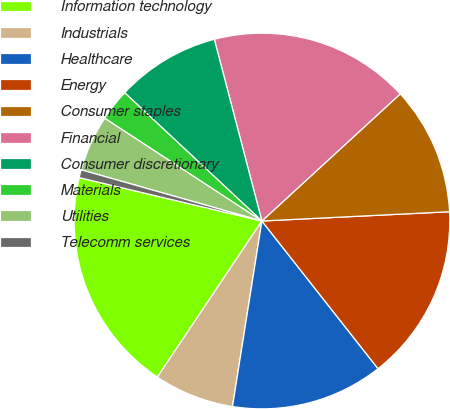Convert chart to OTSL. <chart><loc_0><loc_0><loc_500><loc_500><pie_chart><fcel>Information technology<fcel>Industrials<fcel>Healthcare<fcel>Energy<fcel>Consumer staples<fcel>Financial<fcel>Consumer discretionary<fcel>Materials<fcel>Utilities<fcel>Telecomm services<nl><fcel>19.32%<fcel>6.89%<fcel>13.11%<fcel>15.18%<fcel>11.04%<fcel>17.25%<fcel>8.96%<fcel>2.75%<fcel>4.82%<fcel>0.68%<nl></chart> 